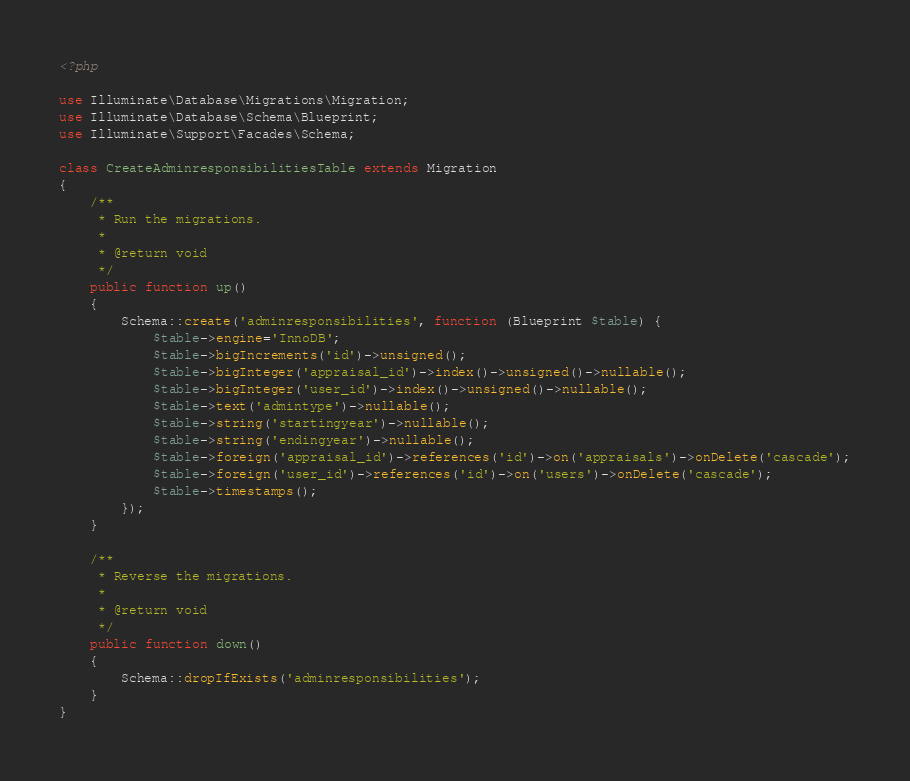<code> <loc_0><loc_0><loc_500><loc_500><_PHP_><?php

use Illuminate\Database\Migrations\Migration;
use Illuminate\Database\Schema\Blueprint;
use Illuminate\Support\Facades\Schema;

class CreateAdminresponsibilitiesTable extends Migration
{
    /**
     * Run the migrations.
     *
     * @return void
     */
    public function up()
    {
        Schema::create('adminresponsibilities', function (Blueprint $table) {
            $table->engine='InnoDB';
            $table->bigIncrements('id')->unsigned();
            $table->bigInteger('appraisal_id')->index()->unsigned()->nullable();
            $table->bigInteger('user_id')->index()->unsigned()->nullable();
            $table->text('admintype')->nullable();   
            $table->string('startingyear')->nullable();  
            $table->string('endingyear')->nullable();  
            $table->foreign('appraisal_id')->references('id')->on('appraisals')->onDelete('cascade');
            $table->foreign('user_id')->references('id')->on('users')->onDelete('cascade');
            $table->timestamps();
        });
    }

    /**
     * Reverse the migrations.
     *
     * @return void
     */
    public function down()
    {
        Schema::dropIfExists('adminresponsibilities');
    }
}
</code> 